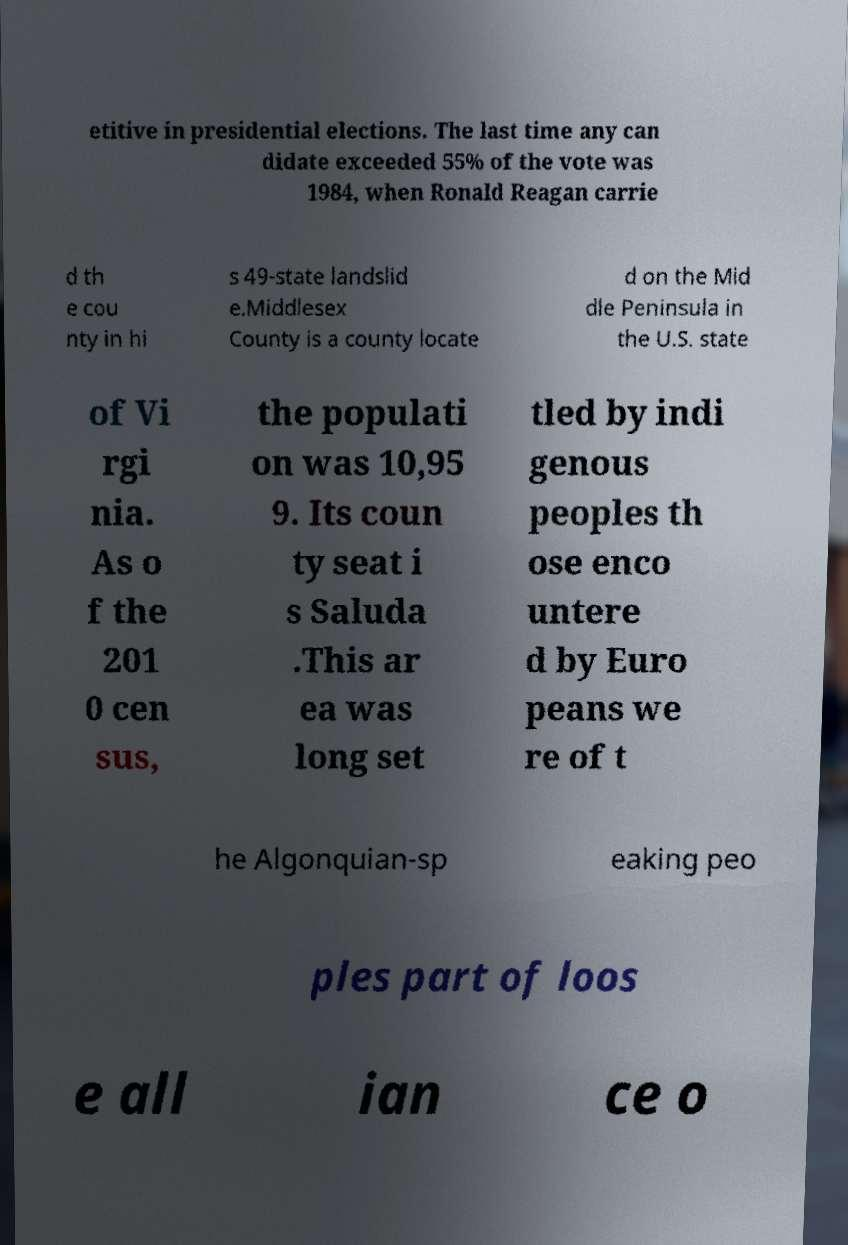Can you read and provide the text displayed in the image?This photo seems to have some interesting text. Can you extract and type it out for me? etitive in presidential elections. The last time any can didate exceeded 55% of the vote was 1984, when Ronald Reagan carrie d th e cou nty in hi s 49-state landslid e.Middlesex County is a county locate d on the Mid dle Peninsula in the U.S. state of Vi rgi nia. As o f the 201 0 cen sus, the populati on was 10,95 9. Its coun ty seat i s Saluda .This ar ea was long set tled by indi genous peoples th ose enco untere d by Euro peans we re of t he Algonquian-sp eaking peo ples part of loos e all ian ce o 